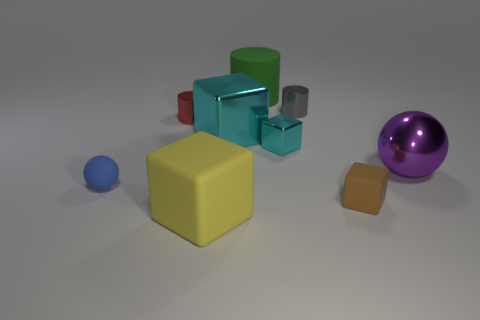What is the size of the metallic thing that is the same color as the tiny metal block?
Your answer should be very brief. Large. The tiny matte thing that is on the left side of the large cube that is behind the large purple shiny object is what shape?
Offer a very short reply. Sphere. Does the purple metallic object have the same shape as the tiny object in front of the tiny blue rubber thing?
Offer a terse response. No. There is a rubber cylinder that is the same size as the purple shiny sphere; what is its color?
Your answer should be compact. Green. Are there fewer large rubber objects in front of the blue rubber object than tiny gray cylinders right of the brown cube?
Your answer should be very brief. No. The large rubber thing that is in front of the sphere on the right side of the blue sphere in front of the rubber cylinder is what shape?
Give a very brief answer. Cube. There is a sphere to the left of the big green matte cylinder; does it have the same color as the rubber cube right of the big yellow rubber thing?
Ensure brevity in your answer.  No. There is a metal object that is the same color as the big shiny block; what is its shape?
Your response must be concise. Cube. What number of rubber objects are either purple things or small cyan things?
Your answer should be compact. 0. What color is the matte block that is behind the big rubber object in front of the ball left of the brown block?
Your response must be concise. Brown. 